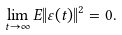<formula> <loc_0><loc_0><loc_500><loc_500>\lim _ { t \rightarrow \infty } E \| \varepsilon ( t ) \| ^ { 2 } = 0 .</formula> 